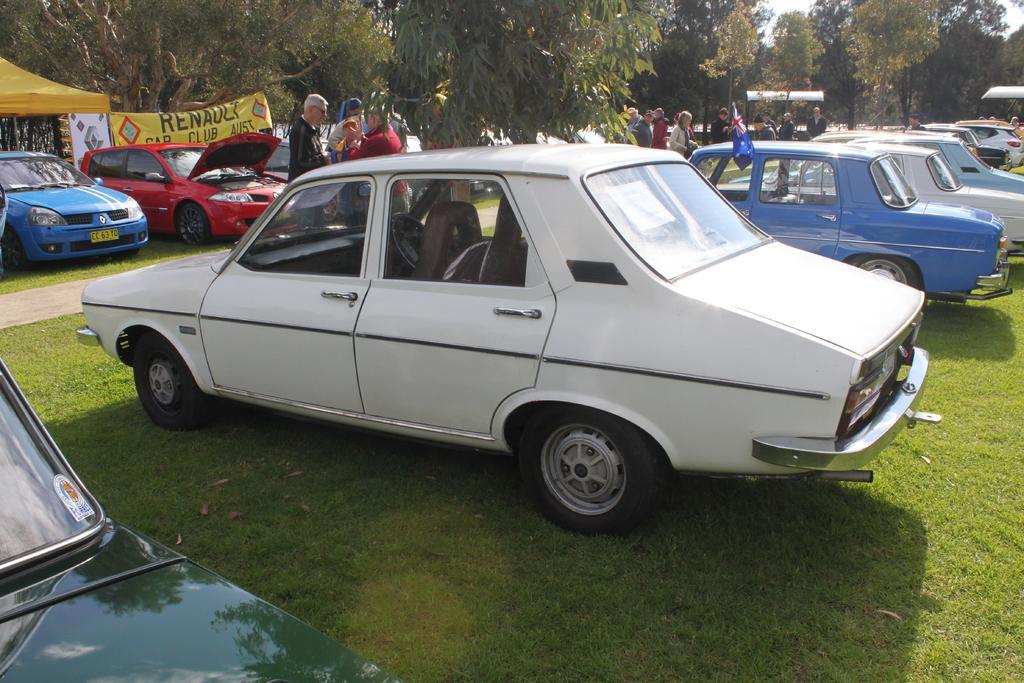Please provide a concise description of this image. In this picture there are cars and there are persons standing. In the background there are trees, there are tents and there is a banner with some text written on it and in the front on the ground there is grass. 